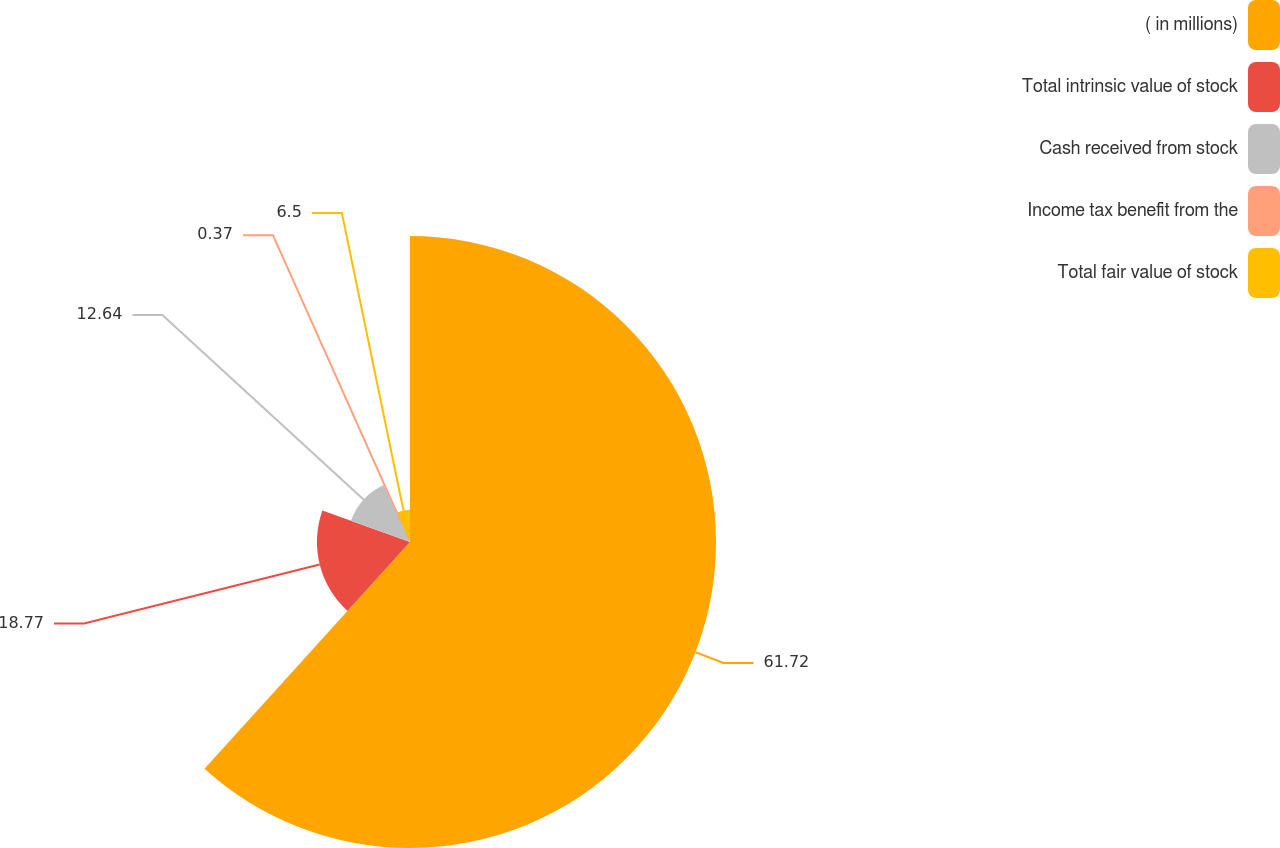Convert chart to OTSL. <chart><loc_0><loc_0><loc_500><loc_500><pie_chart><fcel>( in millions)<fcel>Total intrinsic value of stock<fcel>Cash received from stock<fcel>Income tax benefit from the<fcel>Total fair value of stock<nl><fcel>61.72%<fcel>18.77%<fcel>12.64%<fcel>0.37%<fcel>6.5%<nl></chart> 